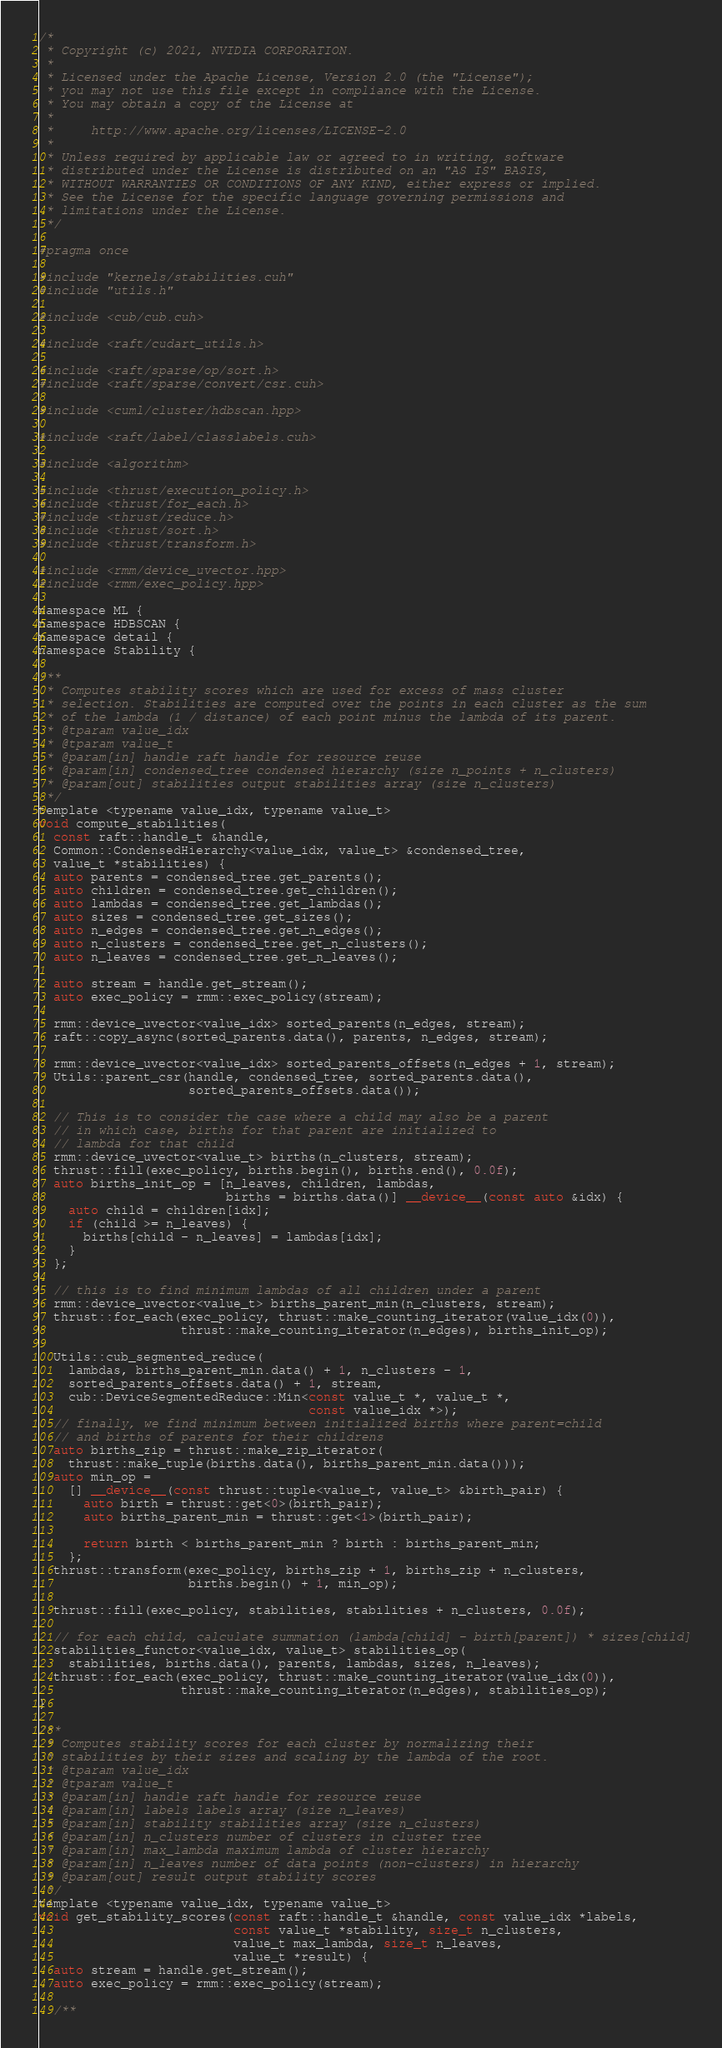<code> <loc_0><loc_0><loc_500><loc_500><_Cuda_>/*
 * Copyright (c) 2021, NVIDIA CORPORATION.
 *
 * Licensed under the Apache License, Version 2.0 (the "License");
 * you may not use this file except in compliance with the License.
 * You may obtain a copy of the License at
 *
 *     http://www.apache.org/licenses/LICENSE-2.0
 *
 * Unless required by applicable law or agreed to in writing, software
 * distributed under the License is distributed on an "AS IS" BASIS,
 * WITHOUT WARRANTIES OR CONDITIONS OF ANY KIND, either express or implied.
 * See the License for the specific language governing permissions and
 * limitations under the License.
 */

#pragma once

#include "kernels/stabilities.cuh"
#include "utils.h"

#include <cub/cub.cuh>

#include <raft/cudart_utils.h>

#include <raft/sparse/op/sort.h>
#include <raft/sparse/convert/csr.cuh>

#include <cuml/cluster/hdbscan.hpp>

#include <raft/label/classlabels.cuh>

#include <algorithm>

#include <thrust/execution_policy.h>
#include <thrust/for_each.h>
#include <thrust/reduce.h>
#include <thrust/sort.h>
#include <thrust/transform.h>

#include <rmm/device_uvector.hpp>
#include <rmm/exec_policy.hpp>

namespace ML {
namespace HDBSCAN {
namespace detail {
namespace Stability {

/**
 * Computes stability scores which are used for excess of mass cluster
 * selection. Stabilities are computed over the points in each cluster as the sum
 * of the lambda (1 / distance) of each point minus the lambda of its parent.
 * @tparam value_idx
 * @tparam value_t
 * @param[in] handle raft handle for resource reuse
 * @param[in] condensed_tree condensed hierarchy (size n_points + n_clusters)
 * @param[out] stabilities output stabilities array (size n_clusters)
 */
template <typename value_idx, typename value_t>
void compute_stabilities(
  const raft::handle_t &handle,
  Common::CondensedHierarchy<value_idx, value_t> &condensed_tree,
  value_t *stabilities) {
  auto parents = condensed_tree.get_parents();
  auto children = condensed_tree.get_children();
  auto lambdas = condensed_tree.get_lambdas();
  auto sizes = condensed_tree.get_sizes();
  auto n_edges = condensed_tree.get_n_edges();
  auto n_clusters = condensed_tree.get_n_clusters();
  auto n_leaves = condensed_tree.get_n_leaves();

  auto stream = handle.get_stream();
  auto exec_policy = rmm::exec_policy(stream);

  rmm::device_uvector<value_idx> sorted_parents(n_edges, stream);
  raft::copy_async(sorted_parents.data(), parents, n_edges, stream);

  rmm::device_uvector<value_idx> sorted_parents_offsets(n_edges + 1, stream);
  Utils::parent_csr(handle, condensed_tree, sorted_parents.data(),
                    sorted_parents_offsets.data());

  // This is to consider the case where a child may also be a parent
  // in which case, births for that parent are initialized to
  // lambda for that child
  rmm::device_uvector<value_t> births(n_clusters, stream);
  thrust::fill(exec_policy, births.begin(), births.end(), 0.0f);
  auto births_init_op = [n_leaves, children, lambdas,
                         births = births.data()] __device__(const auto &idx) {
    auto child = children[idx];
    if (child >= n_leaves) {
      births[child - n_leaves] = lambdas[idx];
    }
  };

  // this is to find minimum lambdas of all children under a parent
  rmm::device_uvector<value_t> births_parent_min(n_clusters, stream);
  thrust::for_each(exec_policy, thrust::make_counting_iterator(value_idx(0)),
                   thrust::make_counting_iterator(n_edges), births_init_op);

  Utils::cub_segmented_reduce(
    lambdas, births_parent_min.data() + 1, n_clusters - 1,
    sorted_parents_offsets.data() + 1, stream,
    cub::DeviceSegmentedReduce::Min<const value_t *, value_t *,
                                    const value_idx *>);
  // finally, we find minimum between initialized births where parent=child
  // and births of parents for their childrens
  auto births_zip = thrust::make_zip_iterator(
    thrust::make_tuple(births.data(), births_parent_min.data()));
  auto min_op =
    [] __device__(const thrust::tuple<value_t, value_t> &birth_pair) {
      auto birth = thrust::get<0>(birth_pair);
      auto births_parent_min = thrust::get<1>(birth_pair);

      return birth < births_parent_min ? birth : births_parent_min;
    };
  thrust::transform(exec_policy, births_zip + 1, births_zip + n_clusters,
                    births.begin() + 1, min_op);

  thrust::fill(exec_policy, stabilities, stabilities + n_clusters, 0.0f);

  // for each child, calculate summation (lambda[child] - birth[parent]) * sizes[child]
  stabilities_functor<value_idx, value_t> stabilities_op(
    stabilities, births.data(), parents, lambdas, sizes, n_leaves);
  thrust::for_each(exec_policy, thrust::make_counting_iterator(value_idx(0)),
                   thrust::make_counting_iterator(n_edges), stabilities_op);
}

/**
 * Computes stability scores for each cluster by normalizing their
 * stabilities by their sizes and scaling by the lambda of the root.
 * @tparam value_idx
 * @tparam value_t
 * @param[in] handle raft handle for resource reuse
 * @param[in] labels labels array (size n_leaves)
 * @param[in] stability stabilities array (size n_clusters)
 * @param[in] n_clusters number of clusters in cluster tree
 * @param[in] max_lambda maximum lambda of cluster hierarchy
 * @param[in] n_leaves number of data points (non-clusters) in hierarchy
 * @param[out] result output stability scores
 */
template <typename value_idx, typename value_t>
void get_stability_scores(const raft::handle_t &handle, const value_idx *labels,
                          const value_t *stability, size_t n_clusters,
                          value_t max_lambda, size_t n_leaves,
                          value_t *result) {
  auto stream = handle.get_stream();
  auto exec_policy = rmm::exec_policy(stream);

  /**</code> 